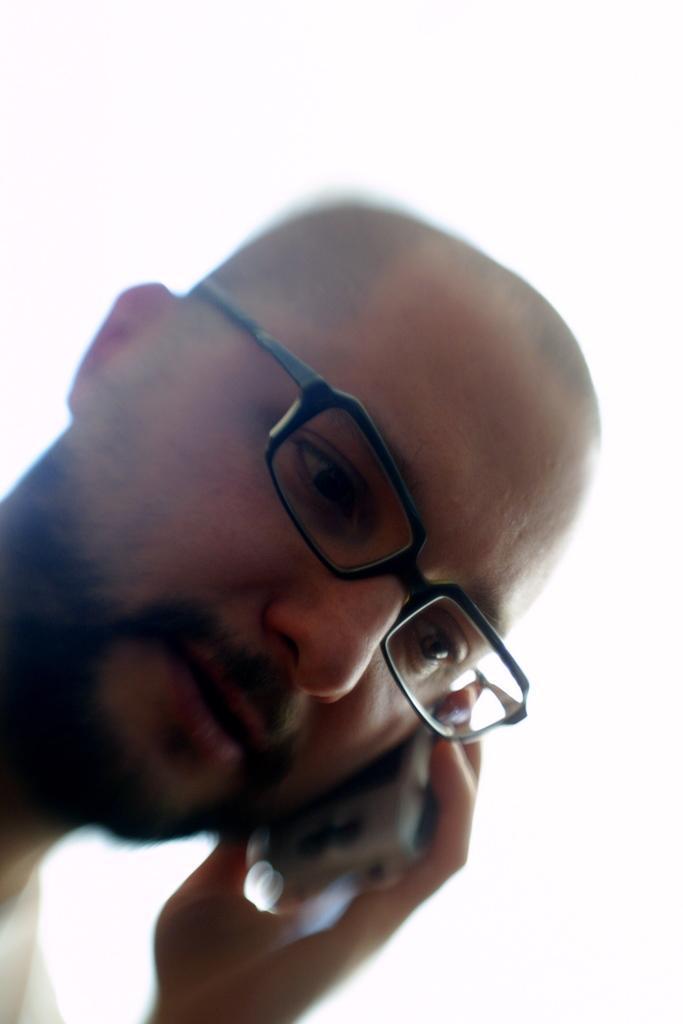In one or two sentences, can you explain what this image depicts? In this image in the center there is a person talking on mobile phone and wearing specs. 